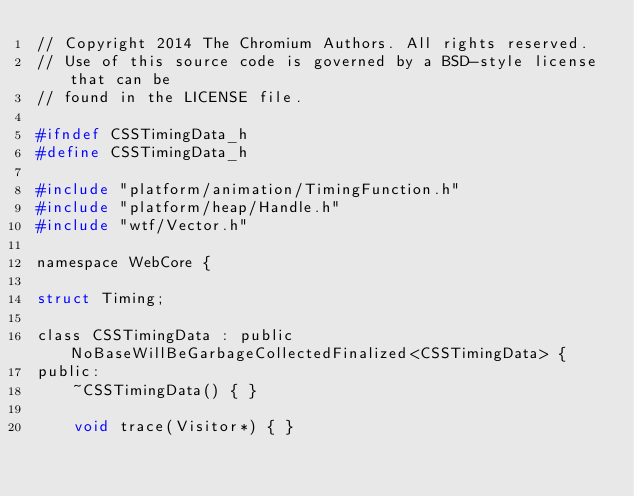Convert code to text. <code><loc_0><loc_0><loc_500><loc_500><_C_>// Copyright 2014 The Chromium Authors. All rights reserved.
// Use of this source code is governed by a BSD-style license that can be
// found in the LICENSE file.

#ifndef CSSTimingData_h
#define CSSTimingData_h

#include "platform/animation/TimingFunction.h"
#include "platform/heap/Handle.h"
#include "wtf/Vector.h"

namespace WebCore {

struct Timing;

class CSSTimingData : public NoBaseWillBeGarbageCollectedFinalized<CSSTimingData> {
public:
    ~CSSTimingData() { }

    void trace(Visitor*) { }
</code> 